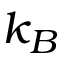Convert formula to latex. <formula><loc_0><loc_0><loc_500><loc_500>k _ { B }</formula> 